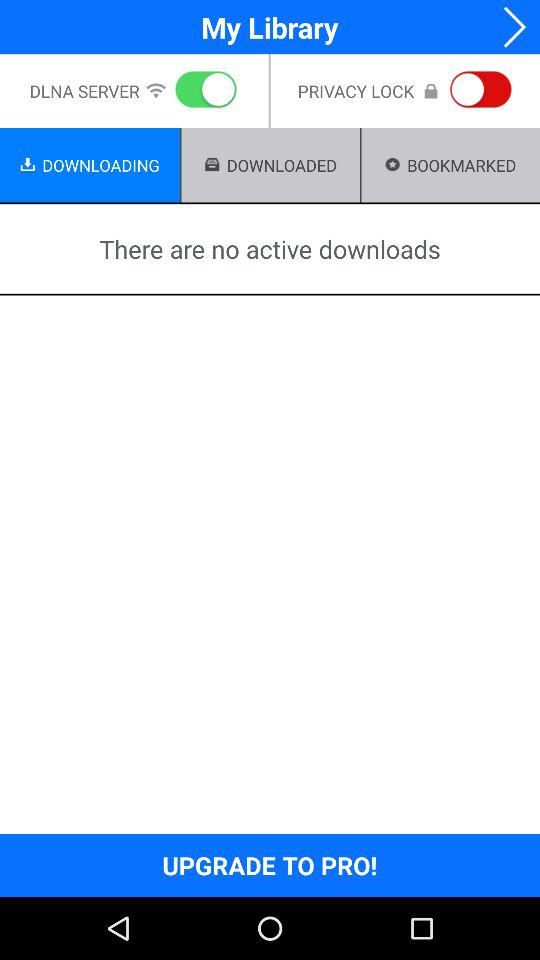What is the status of the "DLNA SERVER"? The status is "on". 